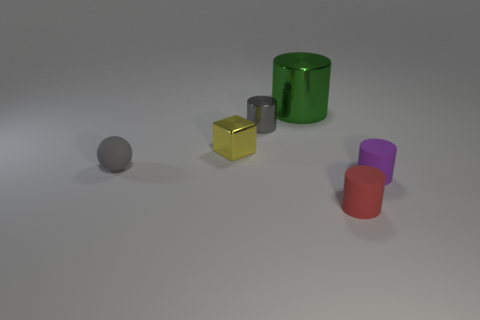Are there any other things that have the same size as the green metal cylinder?
Give a very brief answer. No. There is a yellow shiny cube; is its size the same as the metallic cylinder that is in front of the large green thing?
Offer a very short reply. Yes. There is a purple cylinder to the right of the red cylinder; what material is it?
Offer a terse response. Rubber. How many gray things are behind the rubber cylinder on the left side of the purple matte object?
Provide a succinct answer. 2. Are there any tiny yellow objects of the same shape as the purple rubber object?
Offer a terse response. No. There is a gray object behind the gray rubber sphere; does it have the same size as the green metal cylinder that is right of the yellow object?
Offer a terse response. No. What shape is the metal object that is on the left side of the small metal thing that is to the right of the small yellow object?
Your answer should be compact. Cube. What number of cylinders are the same size as the ball?
Provide a succinct answer. 3. Is there a big metallic cylinder?
Give a very brief answer. Yes. Is there anything else that is the same color as the tiny ball?
Offer a terse response. Yes. 